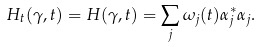Convert formula to latex. <formula><loc_0><loc_0><loc_500><loc_500>H _ { t } ( \gamma , t ) = H ( \gamma , t ) = \sum _ { j } \omega _ { j } ( t ) \alpha _ { j } ^ { * } \alpha _ { j } .</formula> 